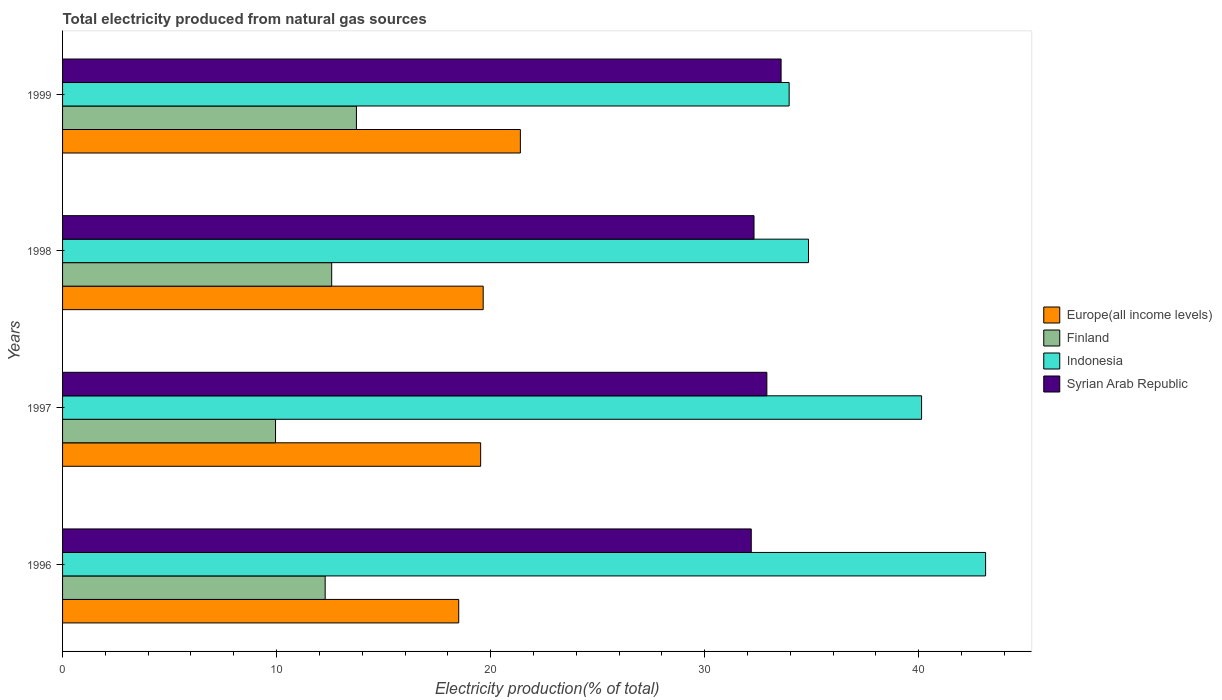How many different coloured bars are there?
Give a very brief answer. 4. How many groups of bars are there?
Your answer should be very brief. 4. Are the number of bars per tick equal to the number of legend labels?
Keep it short and to the point. Yes. Are the number of bars on each tick of the Y-axis equal?
Offer a very short reply. Yes. How many bars are there on the 2nd tick from the bottom?
Offer a terse response. 4. What is the label of the 1st group of bars from the top?
Your answer should be compact. 1999. In how many cases, is the number of bars for a given year not equal to the number of legend labels?
Make the answer very short. 0. What is the total electricity produced in Indonesia in 1997?
Give a very brief answer. 40.14. Across all years, what is the maximum total electricity produced in Finland?
Your answer should be very brief. 13.73. Across all years, what is the minimum total electricity produced in Europe(all income levels)?
Your answer should be very brief. 18.51. In which year was the total electricity produced in Indonesia minimum?
Offer a terse response. 1999. What is the total total electricity produced in Finland in the graph?
Offer a very short reply. 48.53. What is the difference between the total electricity produced in Europe(all income levels) in 1997 and that in 1999?
Offer a very short reply. -1.86. What is the difference between the total electricity produced in Europe(all income levels) in 1998 and the total electricity produced in Indonesia in 1997?
Your answer should be compact. -20.48. What is the average total electricity produced in Europe(all income levels) per year?
Make the answer very short. 19.77. In the year 1998, what is the difference between the total electricity produced in Syrian Arab Republic and total electricity produced in Finland?
Offer a terse response. 19.73. What is the ratio of the total electricity produced in Finland in 1998 to that in 1999?
Your answer should be compact. 0.92. Is the total electricity produced in Syrian Arab Republic in 1996 less than that in 1998?
Your answer should be compact. Yes. Is the difference between the total electricity produced in Syrian Arab Republic in 1998 and 1999 greater than the difference between the total electricity produced in Finland in 1998 and 1999?
Offer a very short reply. No. What is the difference between the highest and the second highest total electricity produced in Finland?
Ensure brevity in your answer.  1.16. What is the difference between the highest and the lowest total electricity produced in Syrian Arab Republic?
Give a very brief answer. 1.39. Is the sum of the total electricity produced in Finland in 1997 and 1998 greater than the maximum total electricity produced in Indonesia across all years?
Make the answer very short. No. What does the 1st bar from the top in 1998 represents?
Your response must be concise. Syrian Arab Republic. What does the 4th bar from the bottom in 1997 represents?
Your answer should be very brief. Syrian Arab Republic. Is it the case that in every year, the sum of the total electricity produced in Indonesia and total electricity produced in Europe(all income levels) is greater than the total electricity produced in Finland?
Offer a very short reply. Yes. What is the difference between two consecutive major ticks on the X-axis?
Ensure brevity in your answer.  10. Where does the legend appear in the graph?
Provide a succinct answer. Center right. How many legend labels are there?
Provide a succinct answer. 4. What is the title of the graph?
Your answer should be compact. Total electricity produced from natural gas sources. What is the label or title of the X-axis?
Give a very brief answer. Electricity production(% of total). What is the label or title of the Y-axis?
Give a very brief answer. Years. What is the Electricity production(% of total) of Europe(all income levels) in 1996?
Make the answer very short. 18.51. What is the Electricity production(% of total) in Finland in 1996?
Provide a succinct answer. 12.27. What is the Electricity production(% of total) of Indonesia in 1996?
Your answer should be very brief. 43.13. What is the Electricity production(% of total) of Syrian Arab Republic in 1996?
Your answer should be compact. 32.18. What is the Electricity production(% of total) in Europe(all income levels) in 1997?
Your answer should be compact. 19.53. What is the Electricity production(% of total) of Finland in 1997?
Keep it short and to the point. 9.95. What is the Electricity production(% of total) in Indonesia in 1997?
Ensure brevity in your answer.  40.14. What is the Electricity production(% of total) of Syrian Arab Republic in 1997?
Offer a very short reply. 32.91. What is the Electricity production(% of total) of Europe(all income levels) in 1998?
Offer a terse response. 19.65. What is the Electricity production(% of total) of Finland in 1998?
Your response must be concise. 12.57. What is the Electricity production(% of total) in Indonesia in 1998?
Your response must be concise. 34.85. What is the Electricity production(% of total) in Syrian Arab Republic in 1998?
Your response must be concise. 32.31. What is the Electricity production(% of total) in Europe(all income levels) in 1999?
Ensure brevity in your answer.  21.39. What is the Electricity production(% of total) in Finland in 1999?
Provide a succinct answer. 13.73. What is the Electricity production(% of total) of Indonesia in 1999?
Your answer should be compact. 33.95. What is the Electricity production(% of total) in Syrian Arab Republic in 1999?
Offer a very short reply. 33.57. Across all years, what is the maximum Electricity production(% of total) in Europe(all income levels)?
Make the answer very short. 21.39. Across all years, what is the maximum Electricity production(% of total) in Finland?
Ensure brevity in your answer.  13.73. Across all years, what is the maximum Electricity production(% of total) of Indonesia?
Your answer should be very brief. 43.13. Across all years, what is the maximum Electricity production(% of total) in Syrian Arab Republic?
Provide a succinct answer. 33.57. Across all years, what is the minimum Electricity production(% of total) of Europe(all income levels)?
Keep it short and to the point. 18.51. Across all years, what is the minimum Electricity production(% of total) of Finland?
Provide a short and direct response. 9.95. Across all years, what is the minimum Electricity production(% of total) of Indonesia?
Provide a short and direct response. 33.95. Across all years, what is the minimum Electricity production(% of total) of Syrian Arab Republic?
Make the answer very short. 32.18. What is the total Electricity production(% of total) in Europe(all income levels) in the graph?
Your answer should be compact. 79.09. What is the total Electricity production(% of total) in Finland in the graph?
Offer a terse response. 48.53. What is the total Electricity production(% of total) in Indonesia in the graph?
Your response must be concise. 152.07. What is the total Electricity production(% of total) of Syrian Arab Republic in the graph?
Give a very brief answer. 130.97. What is the difference between the Electricity production(% of total) of Europe(all income levels) in 1996 and that in 1997?
Make the answer very short. -1.02. What is the difference between the Electricity production(% of total) in Finland in 1996 and that in 1997?
Provide a succinct answer. 2.32. What is the difference between the Electricity production(% of total) of Indonesia in 1996 and that in 1997?
Provide a succinct answer. 2.99. What is the difference between the Electricity production(% of total) in Syrian Arab Republic in 1996 and that in 1997?
Make the answer very short. -0.73. What is the difference between the Electricity production(% of total) in Europe(all income levels) in 1996 and that in 1998?
Ensure brevity in your answer.  -1.14. What is the difference between the Electricity production(% of total) in Finland in 1996 and that in 1998?
Offer a terse response. -0.3. What is the difference between the Electricity production(% of total) of Indonesia in 1996 and that in 1998?
Provide a succinct answer. 8.27. What is the difference between the Electricity production(% of total) of Syrian Arab Republic in 1996 and that in 1998?
Your response must be concise. -0.13. What is the difference between the Electricity production(% of total) of Europe(all income levels) in 1996 and that in 1999?
Keep it short and to the point. -2.88. What is the difference between the Electricity production(% of total) of Finland in 1996 and that in 1999?
Give a very brief answer. -1.46. What is the difference between the Electricity production(% of total) in Indonesia in 1996 and that in 1999?
Offer a very short reply. 9.18. What is the difference between the Electricity production(% of total) in Syrian Arab Republic in 1996 and that in 1999?
Give a very brief answer. -1.39. What is the difference between the Electricity production(% of total) of Europe(all income levels) in 1997 and that in 1998?
Provide a short and direct response. -0.12. What is the difference between the Electricity production(% of total) in Finland in 1997 and that in 1998?
Provide a succinct answer. -2.62. What is the difference between the Electricity production(% of total) in Indonesia in 1997 and that in 1998?
Provide a succinct answer. 5.28. What is the difference between the Electricity production(% of total) of Syrian Arab Republic in 1997 and that in 1998?
Offer a very short reply. 0.6. What is the difference between the Electricity production(% of total) of Europe(all income levels) in 1997 and that in 1999?
Offer a terse response. -1.86. What is the difference between the Electricity production(% of total) in Finland in 1997 and that in 1999?
Give a very brief answer. -3.78. What is the difference between the Electricity production(% of total) in Indonesia in 1997 and that in 1999?
Ensure brevity in your answer.  6.19. What is the difference between the Electricity production(% of total) of Syrian Arab Republic in 1997 and that in 1999?
Offer a terse response. -0.66. What is the difference between the Electricity production(% of total) of Europe(all income levels) in 1998 and that in 1999?
Offer a terse response. -1.74. What is the difference between the Electricity production(% of total) of Finland in 1998 and that in 1999?
Ensure brevity in your answer.  -1.16. What is the difference between the Electricity production(% of total) of Indonesia in 1998 and that in 1999?
Offer a terse response. 0.9. What is the difference between the Electricity production(% of total) in Syrian Arab Republic in 1998 and that in 1999?
Provide a succinct answer. -1.27. What is the difference between the Electricity production(% of total) of Europe(all income levels) in 1996 and the Electricity production(% of total) of Finland in 1997?
Give a very brief answer. 8.56. What is the difference between the Electricity production(% of total) of Europe(all income levels) in 1996 and the Electricity production(% of total) of Indonesia in 1997?
Give a very brief answer. -21.63. What is the difference between the Electricity production(% of total) in Europe(all income levels) in 1996 and the Electricity production(% of total) in Syrian Arab Republic in 1997?
Give a very brief answer. -14.4. What is the difference between the Electricity production(% of total) of Finland in 1996 and the Electricity production(% of total) of Indonesia in 1997?
Your answer should be very brief. -27.87. What is the difference between the Electricity production(% of total) in Finland in 1996 and the Electricity production(% of total) in Syrian Arab Republic in 1997?
Provide a succinct answer. -20.64. What is the difference between the Electricity production(% of total) in Indonesia in 1996 and the Electricity production(% of total) in Syrian Arab Republic in 1997?
Ensure brevity in your answer.  10.22. What is the difference between the Electricity production(% of total) of Europe(all income levels) in 1996 and the Electricity production(% of total) of Finland in 1998?
Keep it short and to the point. 5.94. What is the difference between the Electricity production(% of total) of Europe(all income levels) in 1996 and the Electricity production(% of total) of Indonesia in 1998?
Your response must be concise. -16.34. What is the difference between the Electricity production(% of total) of Europe(all income levels) in 1996 and the Electricity production(% of total) of Syrian Arab Republic in 1998?
Provide a succinct answer. -13.8. What is the difference between the Electricity production(% of total) in Finland in 1996 and the Electricity production(% of total) in Indonesia in 1998?
Offer a very short reply. -22.58. What is the difference between the Electricity production(% of total) in Finland in 1996 and the Electricity production(% of total) in Syrian Arab Republic in 1998?
Provide a succinct answer. -20.04. What is the difference between the Electricity production(% of total) of Indonesia in 1996 and the Electricity production(% of total) of Syrian Arab Republic in 1998?
Your response must be concise. 10.82. What is the difference between the Electricity production(% of total) of Europe(all income levels) in 1996 and the Electricity production(% of total) of Finland in 1999?
Offer a terse response. 4.78. What is the difference between the Electricity production(% of total) of Europe(all income levels) in 1996 and the Electricity production(% of total) of Indonesia in 1999?
Keep it short and to the point. -15.44. What is the difference between the Electricity production(% of total) of Europe(all income levels) in 1996 and the Electricity production(% of total) of Syrian Arab Republic in 1999?
Provide a short and direct response. -15.06. What is the difference between the Electricity production(% of total) in Finland in 1996 and the Electricity production(% of total) in Indonesia in 1999?
Offer a very short reply. -21.68. What is the difference between the Electricity production(% of total) in Finland in 1996 and the Electricity production(% of total) in Syrian Arab Republic in 1999?
Your answer should be compact. -21.3. What is the difference between the Electricity production(% of total) of Indonesia in 1996 and the Electricity production(% of total) of Syrian Arab Republic in 1999?
Ensure brevity in your answer.  9.56. What is the difference between the Electricity production(% of total) in Europe(all income levels) in 1997 and the Electricity production(% of total) in Finland in 1998?
Provide a succinct answer. 6.96. What is the difference between the Electricity production(% of total) in Europe(all income levels) in 1997 and the Electricity production(% of total) in Indonesia in 1998?
Give a very brief answer. -15.32. What is the difference between the Electricity production(% of total) in Europe(all income levels) in 1997 and the Electricity production(% of total) in Syrian Arab Republic in 1998?
Your response must be concise. -12.77. What is the difference between the Electricity production(% of total) in Finland in 1997 and the Electricity production(% of total) in Indonesia in 1998?
Keep it short and to the point. -24.9. What is the difference between the Electricity production(% of total) in Finland in 1997 and the Electricity production(% of total) in Syrian Arab Republic in 1998?
Your response must be concise. -22.36. What is the difference between the Electricity production(% of total) of Indonesia in 1997 and the Electricity production(% of total) of Syrian Arab Republic in 1998?
Provide a succinct answer. 7.83. What is the difference between the Electricity production(% of total) of Europe(all income levels) in 1997 and the Electricity production(% of total) of Finland in 1999?
Offer a very short reply. 5.8. What is the difference between the Electricity production(% of total) in Europe(all income levels) in 1997 and the Electricity production(% of total) in Indonesia in 1999?
Provide a succinct answer. -14.41. What is the difference between the Electricity production(% of total) of Europe(all income levels) in 1997 and the Electricity production(% of total) of Syrian Arab Republic in 1999?
Your response must be concise. -14.04. What is the difference between the Electricity production(% of total) in Finland in 1997 and the Electricity production(% of total) in Indonesia in 1999?
Provide a succinct answer. -24. What is the difference between the Electricity production(% of total) of Finland in 1997 and the Electricity production(% of total) of Syrian Arab Republic in 1999?
Your answer should be compact. -23.62. What is the difference between the Electricity production(% of total) of Indonesia in 1997 and the Electricity production(% of total) of Syrian Arab Republic in 1999?
Ensure brevity in your answer.  6.56. What is the difference between the Electricity production(% of total) of Europe(all income levels) in 1998 and the Electricity production(% of total) of Finland in 1999?
Offer a terse response. 5.92. What is the difference between the Electricity production(% of total) of Europe(all income levels) in 1998 and the Electricity production(% of total) of Indonesia in 1999?
Keep it short and to the point. -14.3. What is the difference between the Electricity production(% of total) of Europe(all income levels) in 1998 and the Electricity production(% of total) of Syrian Arab Republic in 1999?
Provide a short and direct response. -13.92. What is the difference between the Electricity production(% of total) of Finland in 1998 and the Electricity production(% of total) of Indonesia in 1999?
Your response must be concise. -21.37. What is the difference between the Electricity production(% of total) of Finland in 1998 and the Electricity production(% of total) of Syrian Arab Republic in 1999?
Keep it short and to the point. -21. What is the difference between the Electricity production(% of total) of Indonesia in 1998 and the Electricity production(% of total) of Syrian Arab Republic in 1999?
Make the answer very short. 1.28. What is the average Electricity production(% of total) of Europe(all income levels) per year?
Keep it short and to the point. 19.77. What is the average Electricity production(% of total) in Finland per year?
Make the answer very short. 12.13. What is the average Electricity production(% of total) of Indonesia per year?
Your response must be concise. 38.02. What is the average Electricity production(% of total) in Syrian Arab Republic per year?
Offer a very short reply. 32.74. In the year 1996, what is the difference between the Electricity production(% of total) of Europe(all income levels) and Electricity production(% of total) of Finland?
Your answer should be compact. 6.24. In the year 1996, what is the difference between the Electricity production(% of total) of Europe(all income levels) and Electricity production(% of total) of Indonesia?
Ensure brevity in your answer.  -24.62. In the year 1996, what is the difference between the Electricity production(% of total) in Europe(all income levels) and Electricity production(% of total) in Syrian Arab Republic?
Your answer should be compact. -13.67. In the year 1996, what is the difference between the Electricity production(% of total) in Finland and Electricity production(% of total) in Indonesia?
Give a very brief answer. -30.86. In the year 1996, what is the difference between the Electricity production(% of total) of Finland and Electricity production(% of total) of Syrian Arab Republic?
Provide a short and direct response. -19.91. In the year 1996, what is the difference between the Electricity production(% of total) in Indonesia and Electricity production(% of total) in Syrian Arab Republic?
Give a very brief answer. 10.95. In the year 1997, what is the difference between the Electricity production(% of total) of Europe(all income levels) and Electricity production(% of total) of Finland?
Keep it short and to the point. 9.58. In the year 1997, what is the difference between the Electricity production(% of total) in Europe(all income levels) and Electricity production(% of total) in Indonesia?
Offer a very short reply. -20.6. In the year 1997, what is the difference between the Electricity production(% of total) of Europe(all income levels) and Electricity production(% of total) of Syrian Arab Republic?
Ensure brevity in your answer.  -13.37. In the year 1997, what is the difference between the Electricity production(% of total) of Finland and Electricity production(% of total) of Indonesia?
Make the answer very short. -30.19. In the year 1997, what is the difference between the Electricity production(% of total) of Finland and Electricity production(% of total) of Syrian Arab Republic?
Provide a short and direct response. -22.96. In the year 1997, what is the difference between the Electricity production(% of total) of Indonesia and Electricity production(% of total) of Syrian Arab Republic?
Your response must be concise. 7.23. In the year 1998, what is the difference between the Electricity production(% of total) of Europe(all income levels) and Electricity production(% of total) of Finland?
Offer a terse response. 7.08. In the year 1998, what is the difference between the Electricity production(% of total) of Europe(all income levels) and Electricity production(% of total) of Indonesia?
Your response must be concise. -15.2. In the year 1998, what is the difference between the Electricity production(% of total) of Europe(all income levels) and Electricity production(% of total) of Syrian Arab Republic?
Your answer should be very brief. -12.65. In the year 1998, what is the difference between the Electricity production(% of total) of Finland and Electricity production(% of total) of Indonesia?
Make the answer very short. -22.28. In the year 1998, what is the difference between the Electricity production(% of total) of Finland and Electricity production(% of total) of Syrian Arab Republic?
Ensure brevity in your answer.  -19.73. In the year 1998, what is the difference between the Electricity production(% of total) of Indonesia and Electricity production(% of total) of Syrian Arab Republic?
Offer a terse response. 2.55. In the year 1999, what is the difference between the Electricity production(% of total) in Europe(all income levels) and Electricity production(% of total) in Finland?
Offer a terse response. 7.66. In the year 1999, what is the difference between the Electricity production(% of total) in Europe(all income levels) and Electricity production(% of total) in Indonesia?
Your answer should be compact. -12.56. In the year 1999, what is the difference between the Electricity production(% of total) of Europe(all income levels) and Electricity production(% of total) of Syrian Arab Republic?
Provide a succinct answer. -12.18. In the year 1999, what is the difference between the Electricity production(% of total) of Finland and Electricity production(% of total) of Indonesia?
Ensure brevity in your answer.  -20.22. In the year 1999, what is the difference between the Electricity production(% of total) in Finland and Electricity production(% of total) in Syrian Arab Republic?
Give a very brief answer. -19.84. In the year 1999, what is the difference between the Electricity production(% of total) in Indonesia and Electricity production(% of total) in Syrian Arab Republic?
Ensure brevity in your answer.  0.38. What is the ratio of the Electricity production(% of total) in Europe(all income levels) in 1996 to that in 1997?
Your answer should be very brief. 0.95. What is the ratio of the Electricity production(% of total) of Finland in 1996 to that in 1997?
Provide a short and direct response. 1.23. What is the ratio of the Electricity production(% of total) of Indonesia in 1996 to that in 1997?
Give a very brief answer. 1.07. What is the ratio of the Electricity production(% of total) of Syrian Arab Republic in 1996 to that in 1997?
Provide a succinct answer. 0.98. What is the ratio of the Electricity production(% of total) in Europe(all income levels) in 1996 to that in 1998?
Ensure brevity in your answer.  0.94. What is the ratio of the Electricity production(% of total) in Finland in 1996 to that in 1998?
Offer a very short reply. 0.98. What is the ratio of the Electricity production(% of total) in Indonesia in 1996 to that in 1998?
Provide a short and direct response. 1.24. What is the ratio of the Electricity production(% of total) in Syrian Arab Republic in 1996 to that in 1998?
Provide a succinct answer. 1. What is the ratio of the Electricity production(% of total) in Europe(all income levels) in 1996 to that in 1999?
Your response must be concise. 0.87. What is the ratio of the Electricity production(% of total) of Finland in 1996 to that in 1999?
Provide a short and direct response. 0.89. What is the ratio of the Electricity production(% of total) in Indonesia in 1996 to that in 1999?
Make the answer very short. 1.27. What is the ratio of the Electricity production(% of total) in Syrian Arab Republic in 1996 to that in 1999?
Your answer should be very brief. 0.96. What is the ratio of the Electricity production(% of total) of Europe(all income levels) in 1997 to that in 1998?
Make the answer very short. 0.99. What is the ratio of the Electricity production(% of total) in Finland in 1997 to that in 1998?
Offer a very short reply. 0.79. What is the ratio of the Electricity production(% of total) of Indonesia in 1997 to that in 1998?
Ensure brevity in your answer.  1.15. What is the ratio of the Electricity production(% of total) of Syrian Arab Republic in 1997 to that in 1998?
Your answer should be very brief. 1.02. What is the ratio of the Electricity production(% of total) of Europe(all income levels) in 1997 to that in 1999?
Your response must be concise. 0.91. What is the ratio of the Electricity production(% of total) in Finland in 1997 to that in 1999?
Keep it short and to the point. 0.72. What is the ratio of the Electricity production(% of total) in Indonesia in 1997 to that in 1999?
Make the answer very short. 1.18. What is the ratio of the Electricity production(% of total) in Syrian Arab Republic in 1997 to that in 1999?
Your response must be concise. 0.98. What is the ratio of the Electricity production(% of total) of Europe(all income levels) in 1998 to that in 1999?
Provide a succinct answer. 0.92. What is the ratio of the Electricity production(% of total) in Finland in 1998 to that in 1999?
Keep it short and to the point. 0.92. What is the ratio of the Electricity production(% of total) in Indonesia in 1998 to that in 1999?
Your answer should be very brief. 1.03. What is the ratio of the Electricity production(% of total) in Syrian Arab Republic in 1998 to that in 1999?
Your answer should be very brief. 0.96. What is the difference between the highest and the second highest Electricity production(% of total) of Europe(all income levels)?
Give a very brief answer. 1.74. What is the difference between the highest and the second highest Electricity production(% of total) of Finland?
Ensure brevity in your answer.  1.16. What is the difference between the highest and the second highest Electricity production(% of total) in Indonesia?
Your answer should be very brief. 2.99. What is the difference between the highest and the second highest Electricity production(% of total) of Syrian Arab Republic?
Provide a short and direct response. 0.66. What is the difference between the highest and the lowest Electricity production(% of total) of Europe(all income levels)?
Ensure brevity in your answer.  2.88. What is the difference between the highest and the lowest Electricity production(% of total) in Finland?
Your answer should be very brief. 3.78. What is the difference between the highest and the lowest Electricity production(% of total) in Indonesia?
Offer a terse response. 9.18. What is the difference between the highest and the lowest Electricity production(% of total) of Syrian Arab Republic?
Your response must be concise. 1.39. 